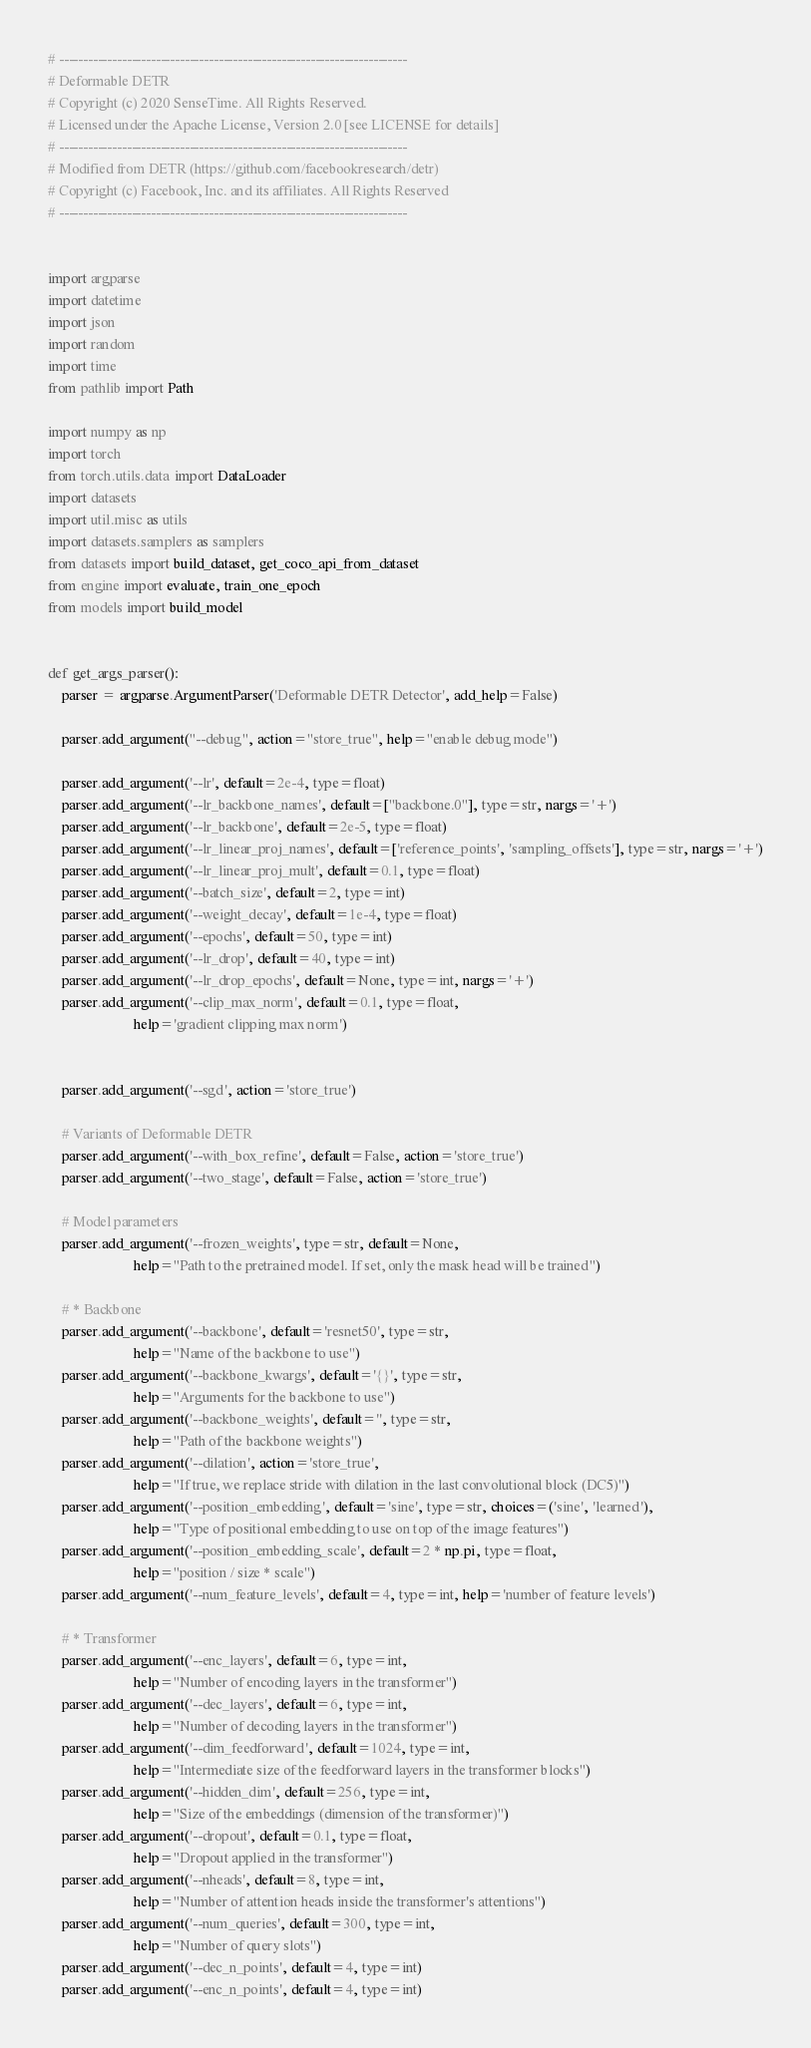<code> <loc_0><loc_0><loc_500><loc_500><_Python_># ------------------------------------------------------------------------
# Deformable DETR
# Copyright (c) 2020 SenseTime. All Rights Reserved.
# Licensed under the Apache License, Version 2.0 [see LICENSE for details]
# ------------------------------------------------------------------------
# Modified from DETR (https://github.com/facebookresearch/detr)
# Copyright (c) Facebook, Inc. and its affiliates. All Rights Reserved
# ------------------------------------------------------------------------


import argparse
import datetime
import json
import random
import time
from pathlib import Path

import numpy as np
import torch
from torch.utils.data import DataLoader
import datasets
import util.misc as utils
import datasets.samplers as samplers
from datasets import build_dataset, get_coco_api_from_dataset
from engine import evaluate, train_one_epoch
from models import build_model


def get_args_parser():
    parser = argparse.ArgumentParser('Deformable DETR Detector', add_help=False)

    parser.add_argument("--debug", action="store_true", help="enable debug mode")
    
    parser.add_argument('--lr', default=2e-4, type=float)
    parser.add_argument('--lr_backbone_names', default=["backbone.0"], type=str, nargs='+')
    parser.add_argument('--lr_backbone', default=2e-5, type=float)
    parser.add_argument('--lr_linear_proj_names', default=['reference_points', 'sampling_offsets'], type=str, nargs='+')
    parser.add_argument('--lr_linear_proj_mult', default=0.1, type=float)
    parser.add_argument('--batch_size', default=2, type=int)
    parser.add_argument('--weight_decay', default=1e-4, type=float)
    parser.add_argument('--epochs', default=50, type=int)
    parser.add_argument('--lr_drop', default=40, type=int)
    parser.add_argument('--lr_drop_epochs', default=None, type=int, nargs='+')
    parser.add_argument('--clip_max_norm', default=0.1, type=float,
                        help='gradient clipping max norm')


    parser.add_argument('--sgd', action='store_true')

    # Variants of Deformable DETR
    parser.add_argument('--with_box_refine', default=False, action='store_true')
    parser.add_argument('--two_stage', default=False, action='store_true')

    # Model parameters
    parser.add_argument('--frozen_weights', type=str, default=None,
                        help="Path to the pretrained model. If set, only the mask head will be trained")

    # * Backbone
    parser.add_argument('--backbone', default='resnet50', type=str,
                        help="Name of the backbone to use")
    parser.add_argument('--backbone_kwargs', default='{}', type=str,
                        help="Arguments for the backbone to use")
    parser.add_argument('--backbone_weights', default='', type=str,
                        help="Path of the backbone weights")
    parser.add_argument('--dilation', action='store_true',
                        help="If true, we replace stride with dilation in the last convolutional block (DC5)")
    parser.add_argument('--position_embedding', default='sine', type=str, choices=('sine', 'learned'),
                        help="Type of positional embedding to use on top of the image features")
    parser.add_argument('--position_embedding_scale', default=2 * np.pi, type=float,
                        help="position / size * scale")
    parser.add_argument('--num_feature_levels', default=4, type=int, help='number of feature levels')

    # * Transformer
    parser.add_argument('--enc_layers', default=6, type=int,
                        help="Number of encoding layers in the transformer")
    parser.add_argument('--dec_layers', default=6, type=int,
                        help="Number of decoding layers in the transformer")
    parser.add_argument('--dim_feedforward', default=1024, type=int,
                        help="Intermediate size of the feedforward layers in the transformer blocks")
    parser.add_argument('--hidden_dim', default=256, type=int,
                        help="Size of the embeddings (dimension of the transformer)")
    parser.add_argument('--dropout', default=0.1, type=float,
                        help="Dropout applied in the transformer")
    parser.add_argument('--nheads', default=8, type=int,
                        help="Number of attention heads inside the transformer's attentions")
    parser.add_argument('--num_queries', default=300, type=int,
                        help="Number of query slots")
    parser.add_argument('--dec_n_points', default=4, type=int)
    parser.add_argument('--enc_n_points', default=4, type=int)
</code> 